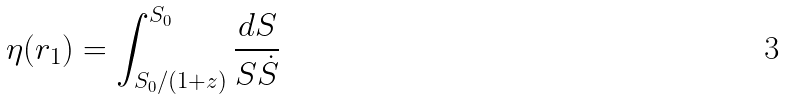Convert formula to latex. <formula><loc_0><loc_0><loc_500><loc_500>\eta ( r _ { 1 } ) = \int _ { S _ { 0 } / ( 1 + z ) } ^ { S _ { 0 } } \frac { d S } { S \dot { S } }</formula> 